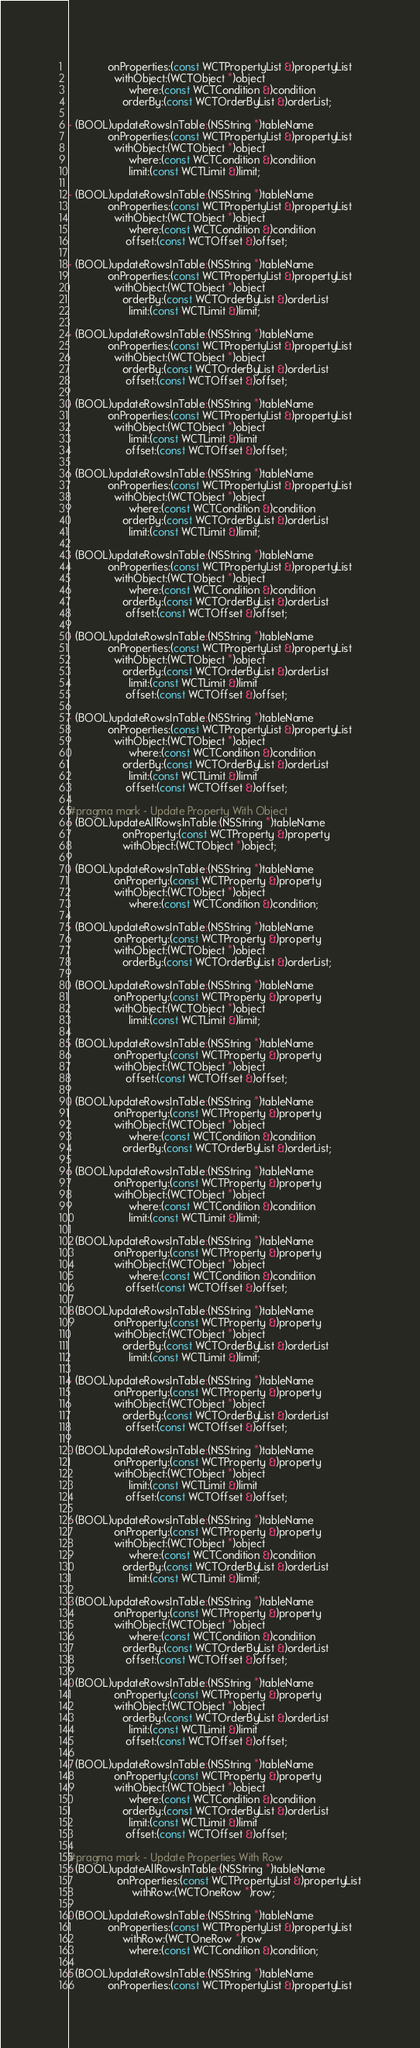Convert code to text. <code><loc_0><loc_0><loc_500><loc_500><_C_>             onProperties:(const WCTPropertyList &)propertyList
               withObject:(WCTObject *)object
                    where:(const WCTCondition &)condition
                  orderBy:(const WCTOrderByList &)orderList;

- (BOOL)updateRowsInTable:(NSString *)tableName
             onProperties:(const WCTPropertyList &)propertyList
               withObject:(WCTObject *)object
                    where:(const WCTCondition &)condition
                    limit:(const WCTLimit &)limit;

- (BOOL)updateRowsInTable:(NSString *)tableName
             onProperties:(const WCTPropertyList &)propertyList
               withObject:(WCTObject *)object
                    where:(const WCTCondition &)condition
                   offset:(const WCTOffset &)offset;

- (BOOL)updateRowsInTable:(NSString *)tableName
             onProperties:(const WCTPropertyList &)propertyList
               withObject:(WCTObject *)object
                  orderBy:(const WCTOrderByList &)orderList
                    limit:(const WCTLimit &)limit;

- (BOOL)updateRowsInTable:(NSString *)tableName
             onProperties:(const WCTPropertyList &)propertyList
               withObject:(WCTObject *)object
                  orderBy:(const WCTOrderByList &)orderList
                   offset:(const WCTOffset &)offset;

- (BOOL)updateRowsInTable:(NSString *)tableName
             onProperties:(const WCTPropertyList &)propertyList
               withObject:(WCTObject *)object
                    limit:(const WCTLimit &)limit
                   offset:(const WCTOffset &)offset;

- (BOOL)updateRowsInTable:(NSString *)tableName
             onProperties:(const WCTPropertyList &)propertyList
               withObject:(WCTObject *)object
                    where:(const WCTCondition &)condition
                  orderBy:(const WCTOrderByList &)orderList
                    limit:(const WCTLimit &)limit;

- (BOOL)updateRowsInTable:(NSString *)tableName
             onProperties:(const WCTPropertyList &)propertyList
               withObject:(WCTObject *)object
                    where:(const WCTCondition &)condition
                  orderBy:(const WCTOrderByList &)orderList
                   offset:(const WCTOffset &)offset;

- (BOOL)updateRowsInTable:(NSString *)tableName
             onProperties:(const WCTPropertyList &)propertyList
               withObject:(WCTObject *)object
                  orderBy:(const WCTOrderByList &)orderList
                    limit:(const WCTLimit &)limit
                   offset:(const WCTOffset &)offset;

- (BOOL)updateRowsInTable:(NSString *)tableName
             onProperties:(const WCTPropertyList &)propertyList
               withObject:(WCTObject *)object
                    where:(const WCTCondition &)condition
                  orderBy:(const WCTOrderByList &)orderList
                    limit:(const WCTLimit &)limit
                   offset:(const WCTOffset &)offset;

#pragma mark - Update Property With Object
- (BOOL)updateAllRowsInTable:(NSString *)tableName
                  onProperty:(const WCTProperty &)property
                  withObject:(WCTObject *)object;

- (BOOL)updateRowsInTable:(NSString *)tableName
               onProperty:(const WCTProperty &)property
               withObject:(WCTObject *)object
                    where:(const WCTCondition &)condition;

- (BOOL)updateRowsInTable:(NSString *)tableName
               onProperty:(const WCTProperty &)property
               withObject:(WCTObject *)object
                  orderBy:(const WCTOrderByList &)orderList;

- (BOOL)updateRowsInTable:(NSString *)tableName
               onProperty:(const WCTProperty &)property
               withObject:(WCTObject *)object
                    limit:(const WCTLimit &)limit;

- (BOOL)updateRowsInTable:(NSString *)tableName
               onProperty:(const WCTProperty &)property
               withObject:(WCTObject *)object
                   offset:(const WCTOffset &)offset;

- (BOOL)updateRowsInTable:(NSString *)tableName
               onProperty:(const WCTProperty &)property
               withObject:(WCTObject *)object
                    where:(const WCTCondition &)condition
                  orderBy:(const WCTOrderByList &)orderList;

- (BOOL)updateRowsInTable:(NSString *)tableName
               onProperty:(const WCTProperty &)property
               withObject:(WCTObject *)object
                    where:(const WCTCondition &)condition
                    limit:(const WCTLimit &)limit;

- (BOOL)updateRowsInTable:(NSString *)tableName
               onProperty:(const WCTProperty &)property
               withObject:(WCTObject *)object
                    where:(const WCTCondition &)condition
                   offset:(const WCTOffset &)offset;

- (BOOL)updateRowsInTable:(NSString *)tableName
               onProperty:(const WCTProperty &)property
               withObject:(WCTObject *)object
                  orderBy:(const WCTOrderByList &)orderList
                    limit:(const WCTLimit &)limit;

- (BOOL)updateRowsInTable:(NSString *)tableName
               onProperty:(const WCTProperty &)property
               withObject:(WCTObject *)object
                  orderBy:(const WCTOrderByList &)orderList
                   offset:(const WCTOffset &)offset;

- (BOOL)updateRowsInTable:(NSString *)tableName
               onProperty:(const WCTProperty &)property
               withObject:(WCTObject *)object
                    limit:(const WCTLimit &)limit
                   offset:(const WCTOffset &)offset;

- (BOOL)updateRowsInTable:(NSString *)tableName
               onProperty:(const WCTProperty &)property
               withObject:(WCTObject *)object
                    where:(const WCTCondition &)condition
                  orderBy:(const WCTOrderByList &)orderList
                    limit:(const WCTLimit &)limit;

- (BOOL)updateRowsInTable:(NSString *)tableName
               onProperty:(const WCTProperty &)property
               withObject:(WCTObject *)object
                    where:(const WCTCondition &)condition
                  orderBy:(const WCTOrderByList &)orderList
                   offset:(const WCTOffset &)offset;

- (BOOL)updateRowsInTable:(NSString *)tableName
               onProperty:(const WCTProperty &)property
               withObject:(WCTObject *)object
                  orderBy:(const WCTOrderByList &)orderList
                    limit:(const WCTLimit &)limit
                   offset:(const WCTOffset &)offset;

- (BOOL)updateRowsInTable:(NSString *)tableName
               onProperty:(const WCTProperty &)property
               withObject:(WCTObject *)object
                    where:(const WCTCondition &)condition
                  orderBy:(const WCTOrderByList &)orderList
                    limit:(const WCTLimit &)limit
                   offset:(const WCTOffset &)offset;

#pragma mark - Update Properties With Row
- (BOOL)updateAllRowsInTable:(NSString *)tableName
                onProperties:(const WCTPropertyList &)propertyList
                     withRow:(WCTOneRow *)row;

- (BOOL)updateRowsInTable:(NSString *)tableName
             onProperties:(const WCTPropertyList &)propertyList
                  withRow:(WCTOneRow *)row
                    where:(const WCTCondition &)condition;

- (BOOL)updateRowsInTable:(NSString *)tableName
             onProperties:(const WCTPropertyList &)propertyList</code> 